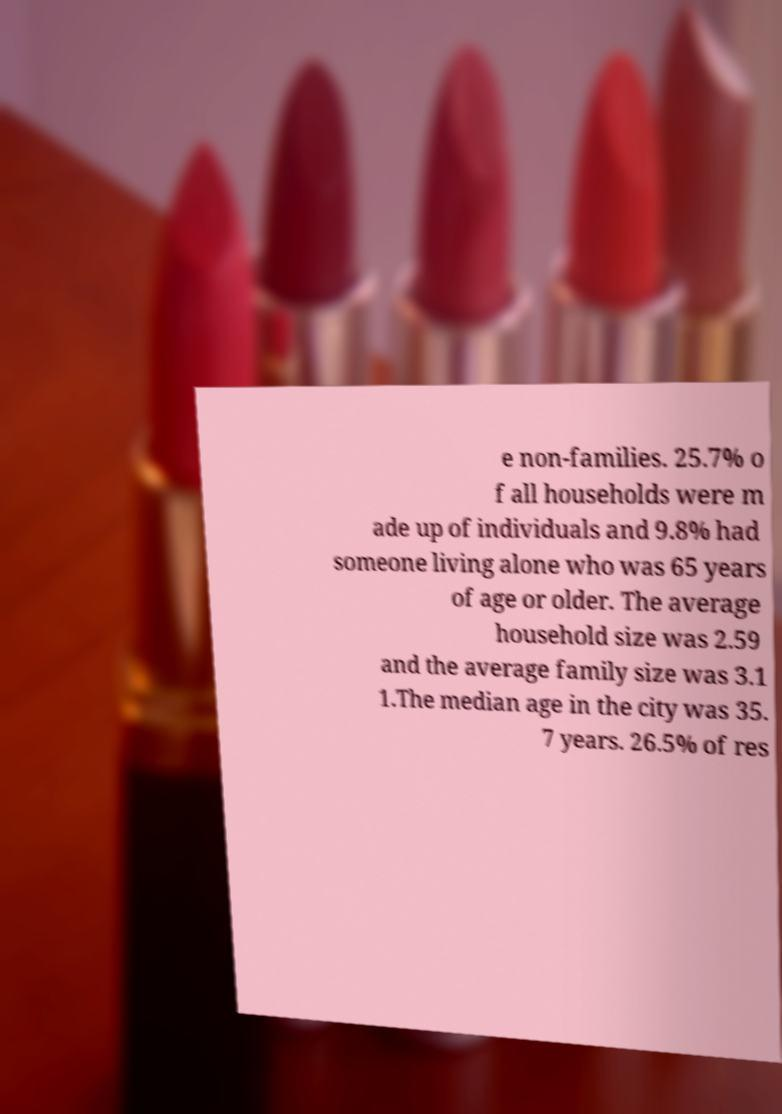Could you extract and type out the text from this image? e non-families. 25.7% o f all households were m ade up of individuals and 9.8% had someone living alone who was 65 years of age or older. The average household size was 2.59 and the average family size was 3.1 1.The median age in the city was 35. 7 years. 26.5% of res 